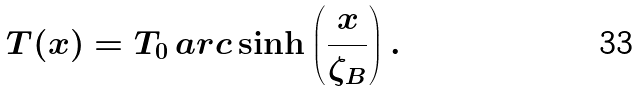<formula> <loc_0><loc_0><loc_500><loc_500>T ( x ) = T _ { 0 } \, a r c \sinh \left ( \frac { x } { \zeta _ { B } } \right ) .</formula> 